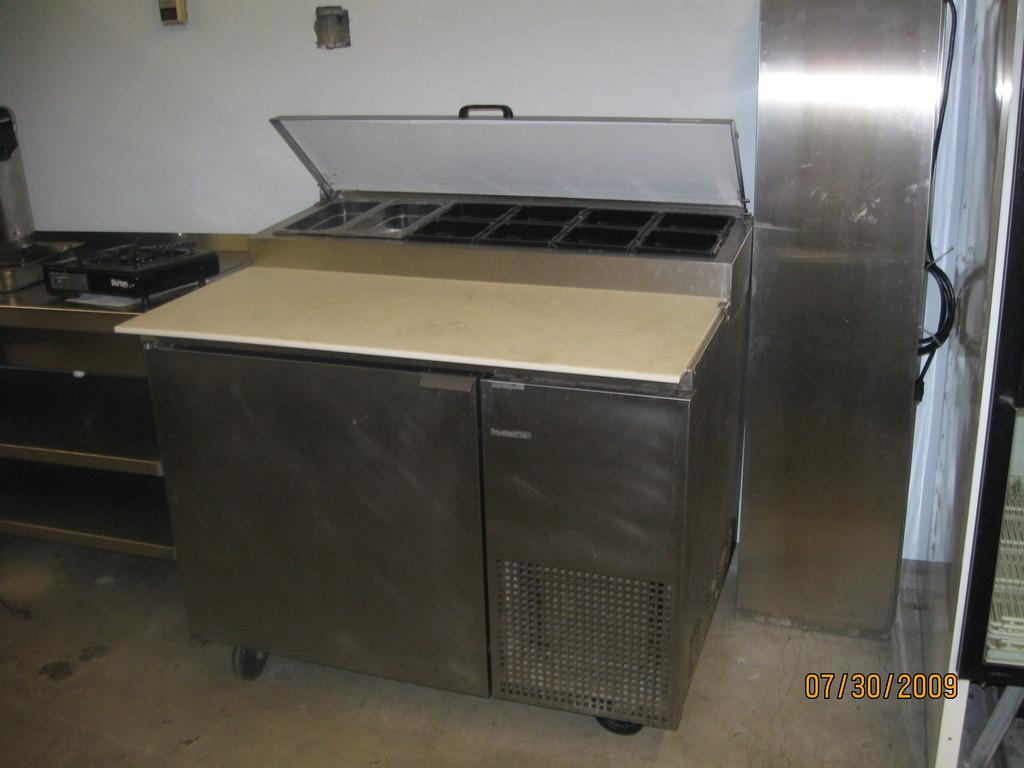<image>
Give a short and clear explanation of the subsequent image. a professional kitchen oven and a small electronic stove that says Birton the front part. 